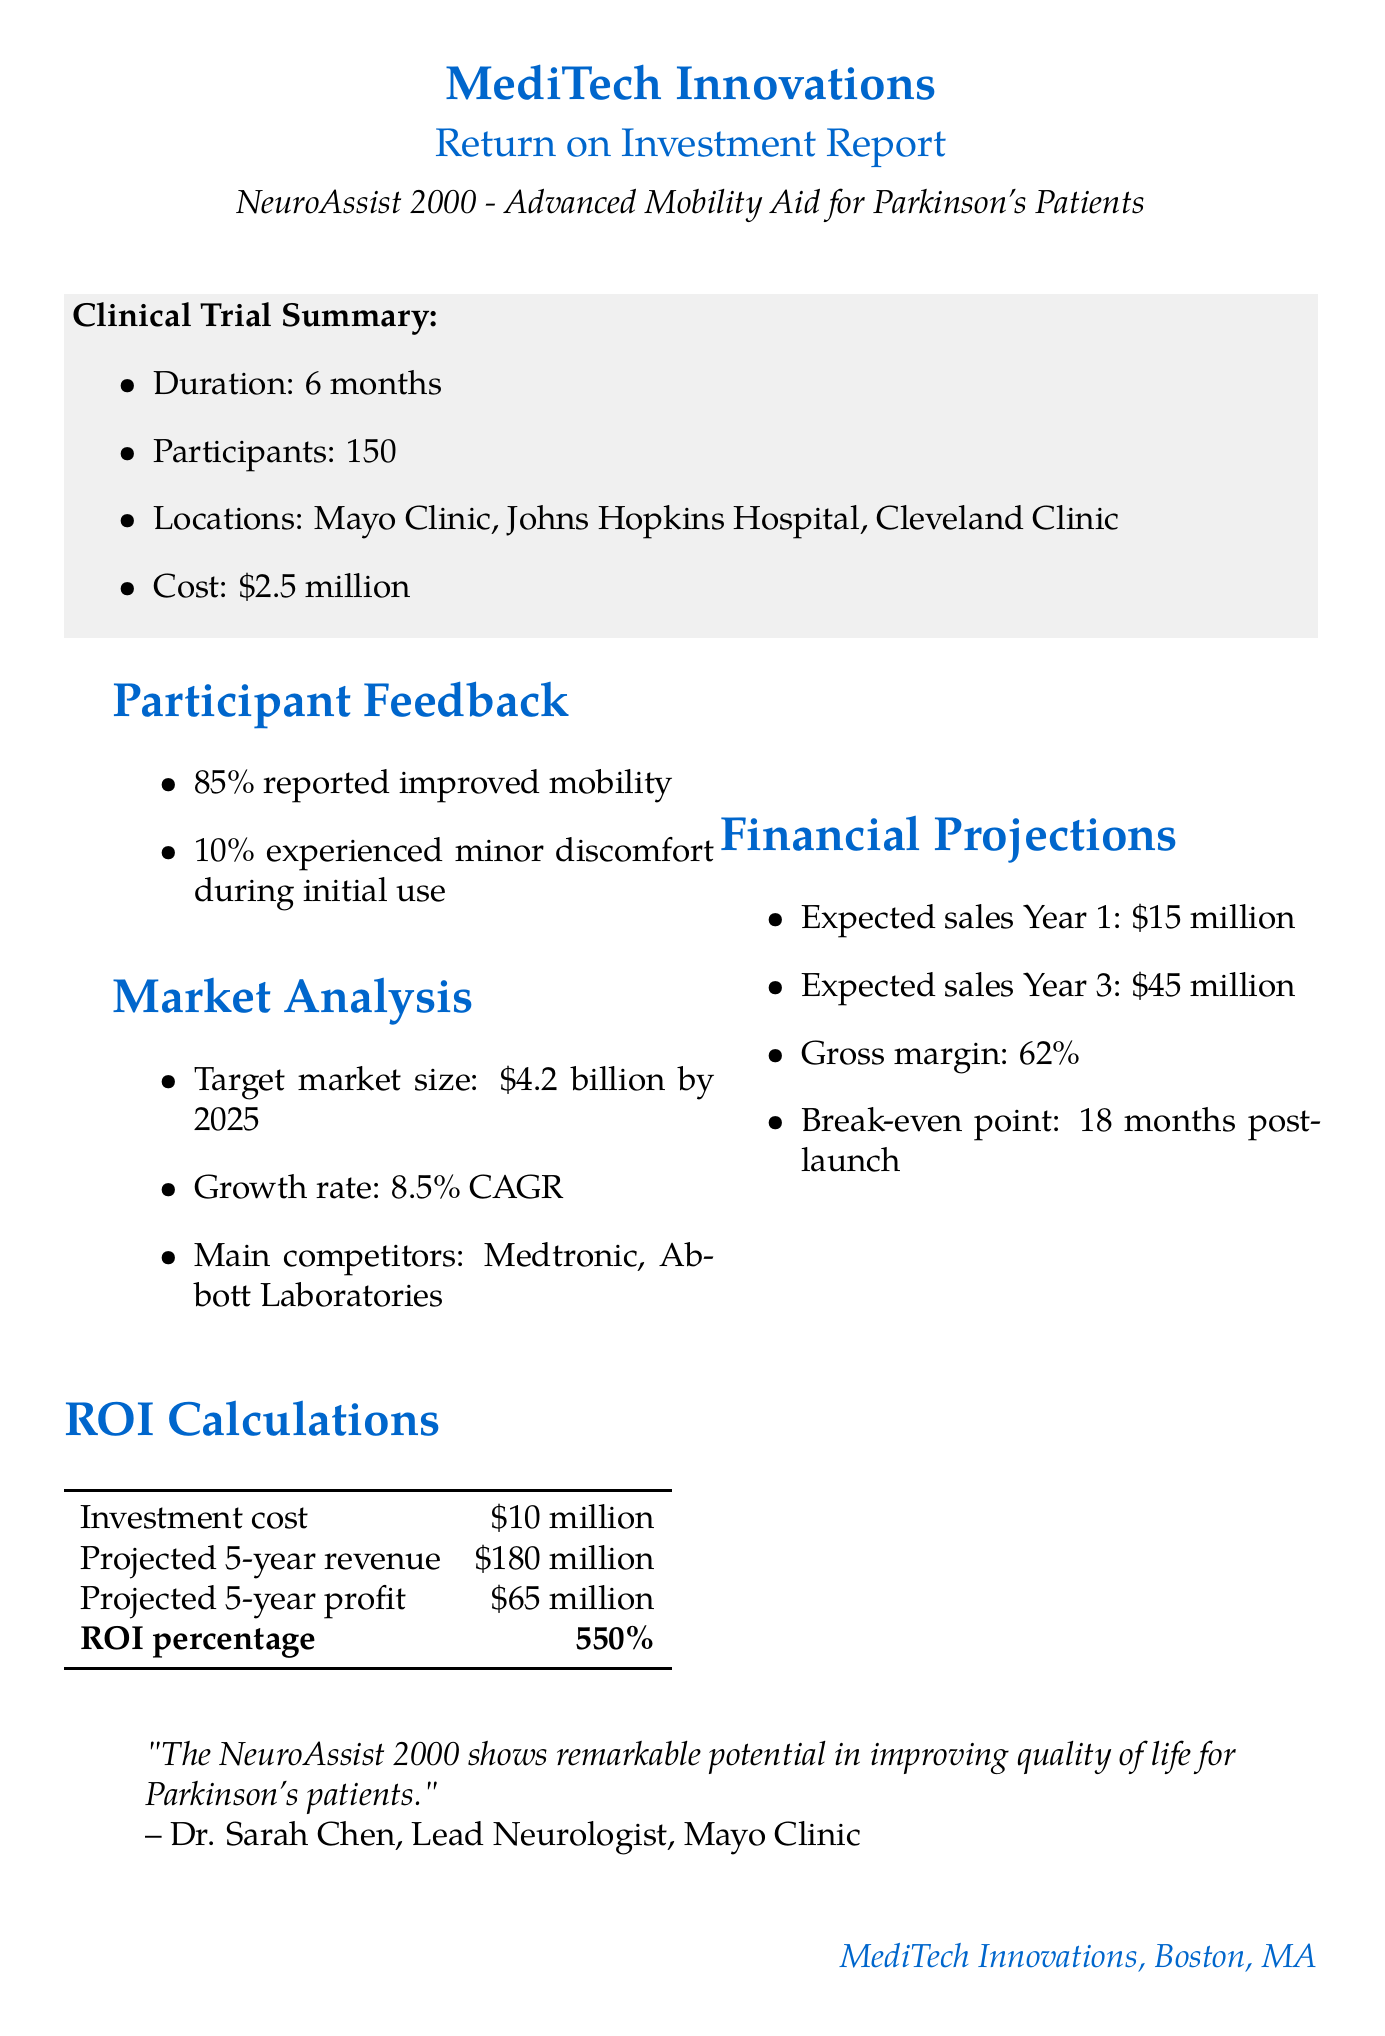What is the name of the product being evaluated? The product being evaluated is "NeuroAssist 2000 - Advanced Mobility Aid for Parkinson's Patients."
Answer: NeuroAssist 2000 How many participants were involved in the clinical trial? The document states there were 150 participants involved in the clinical trial.
Answer: 150 What is the total cost of the clinical trial? The total cost for the clinical trial as mentioned in the document is $2.5 million.
Answer: $2.5 million What percentage of participants reported improved mobility? According to the participant feedback, 85% reported improved mobility.
Answer: 85% What is the expected sales in Year 3? The expected sales in Year 3, as per the financial projections, is $45 million.
Answer: $45 million What is the ROI percentage calculated in the report? The report states the ROI percentage is 550%.
Answer: 550% What is the target market size by 2025? The target market size mentioned in the market analysis is $4.2 billion by 2025.
Answer: $4.2 billion What is the break-even point post-launch? The break-even point is stated to be 18 months post-launch in the financial projections section.
Answer: 18 months Who is the lead neurologist quoted in the report? The lead neurologist quoted is Dr. Sarah Chen from Mayo Clinic.
Answer: Dr. Sarah Chen 